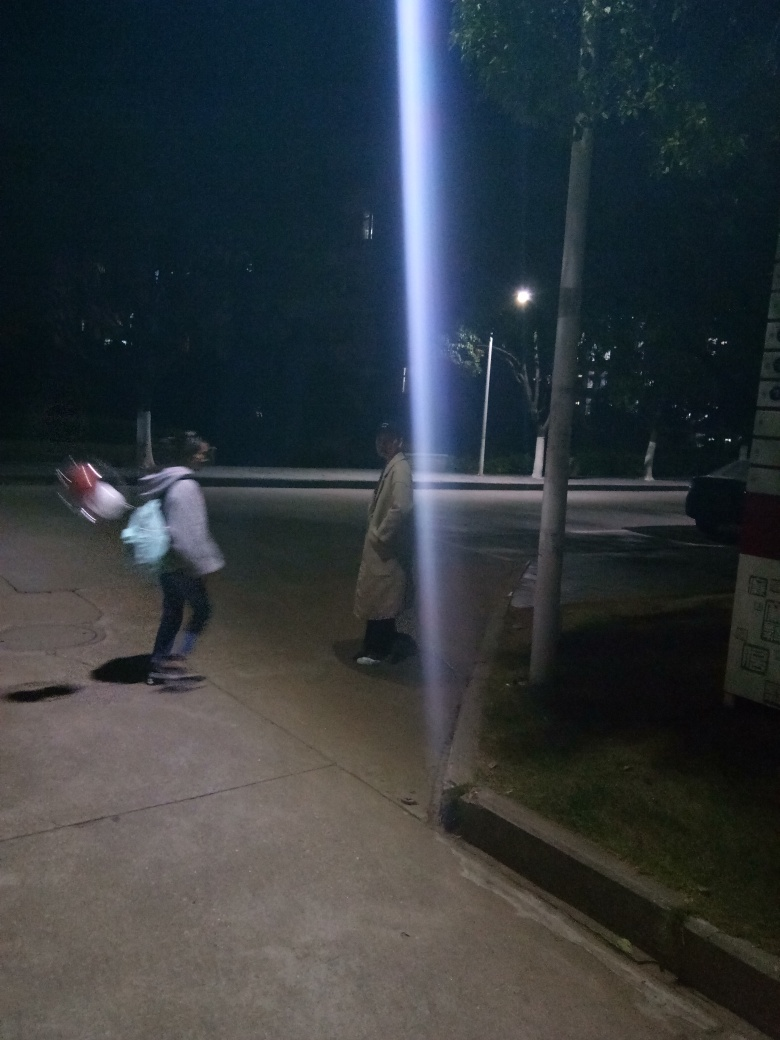Is the main subject, a pedestrian, very blurry and lacking texture details?
 Yes 